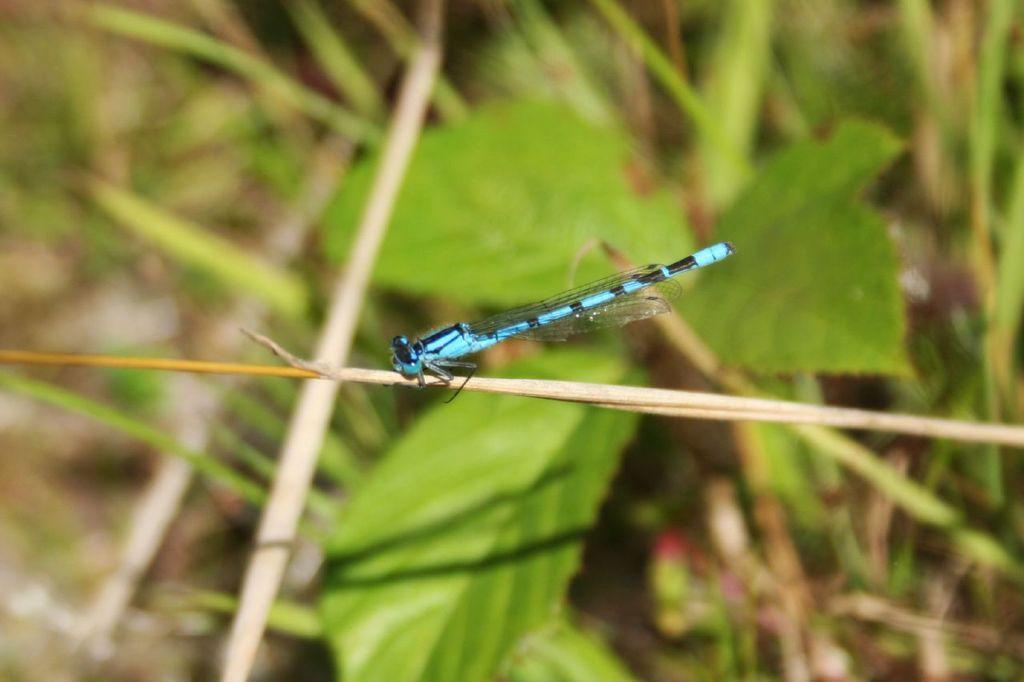Please provide a concise description of this image. In this image we can see an insect on the plant stem. In the background we can see the leaves. 